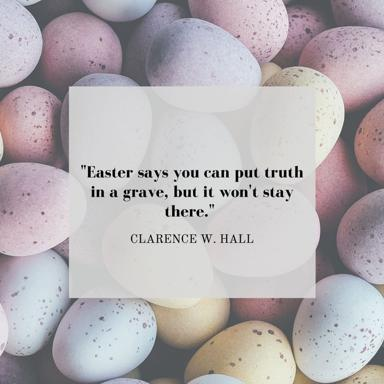What might the placement of the eggs suggest about the interpretation of the quote? The arrangement of the eggs in the image, with some partially obscured and others fully visible, could symbolize the fluctuating visibility of truth. Just as some eggs are not immediately noticeable, truth too can sometimes be hidden or obscured, yet not permanently. The overall cluster of eggs implies unity and collective strength, reflecting the idea that truth, even when buried, will eventually come to light and prevail. This visualization subtly reinforces the enduring nature of truth as celebrated during Easter. 